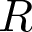Convert formula to latex. <formula><loc_0><loc_0><loc_500><loc_500>R</formula> 